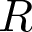Convert formula to latex. <formula><loc_0><loc_0><loc_500><loc_500>R</formula> 